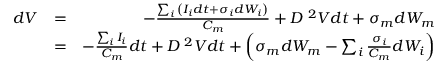<formula> <loc_0><loc_0><loc_500><loc_500>\begin{array} { r l r } { d V } & { = } & { - \frac { \sum _ { i } { \left ( I _ { i } d t + \sigma _ { i } d W _ { i } \right ) } } { C _ { m } } + D \nabla ^ { 2 } V d t + \sigma _ { m } d W _ { m } } \\ & { = } & { - \frac { \sum _ { i } { I _ { i } } } { C _ { m } } d t + D \nabla ^ { 2 } V d t + \left ( \sigma _ { m } d W _ { m } - \sum _ { i } { \frac { \sigma _ { i } } { C _ { m } } d W _ { i } } \right ) } \end{array}</formula> 